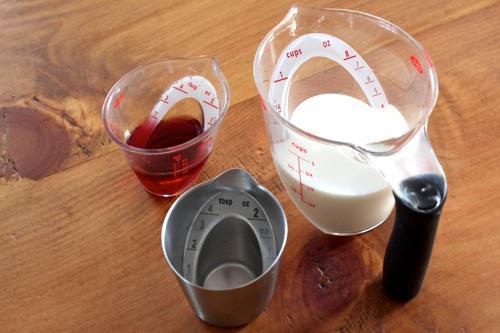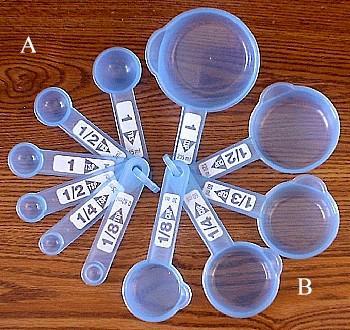The first image is the image on the left, the second image is the image on the right. For the images shown, is this caption "There is at least clear measuring cup in one of the images." true? Answer yes or no. Yes. 